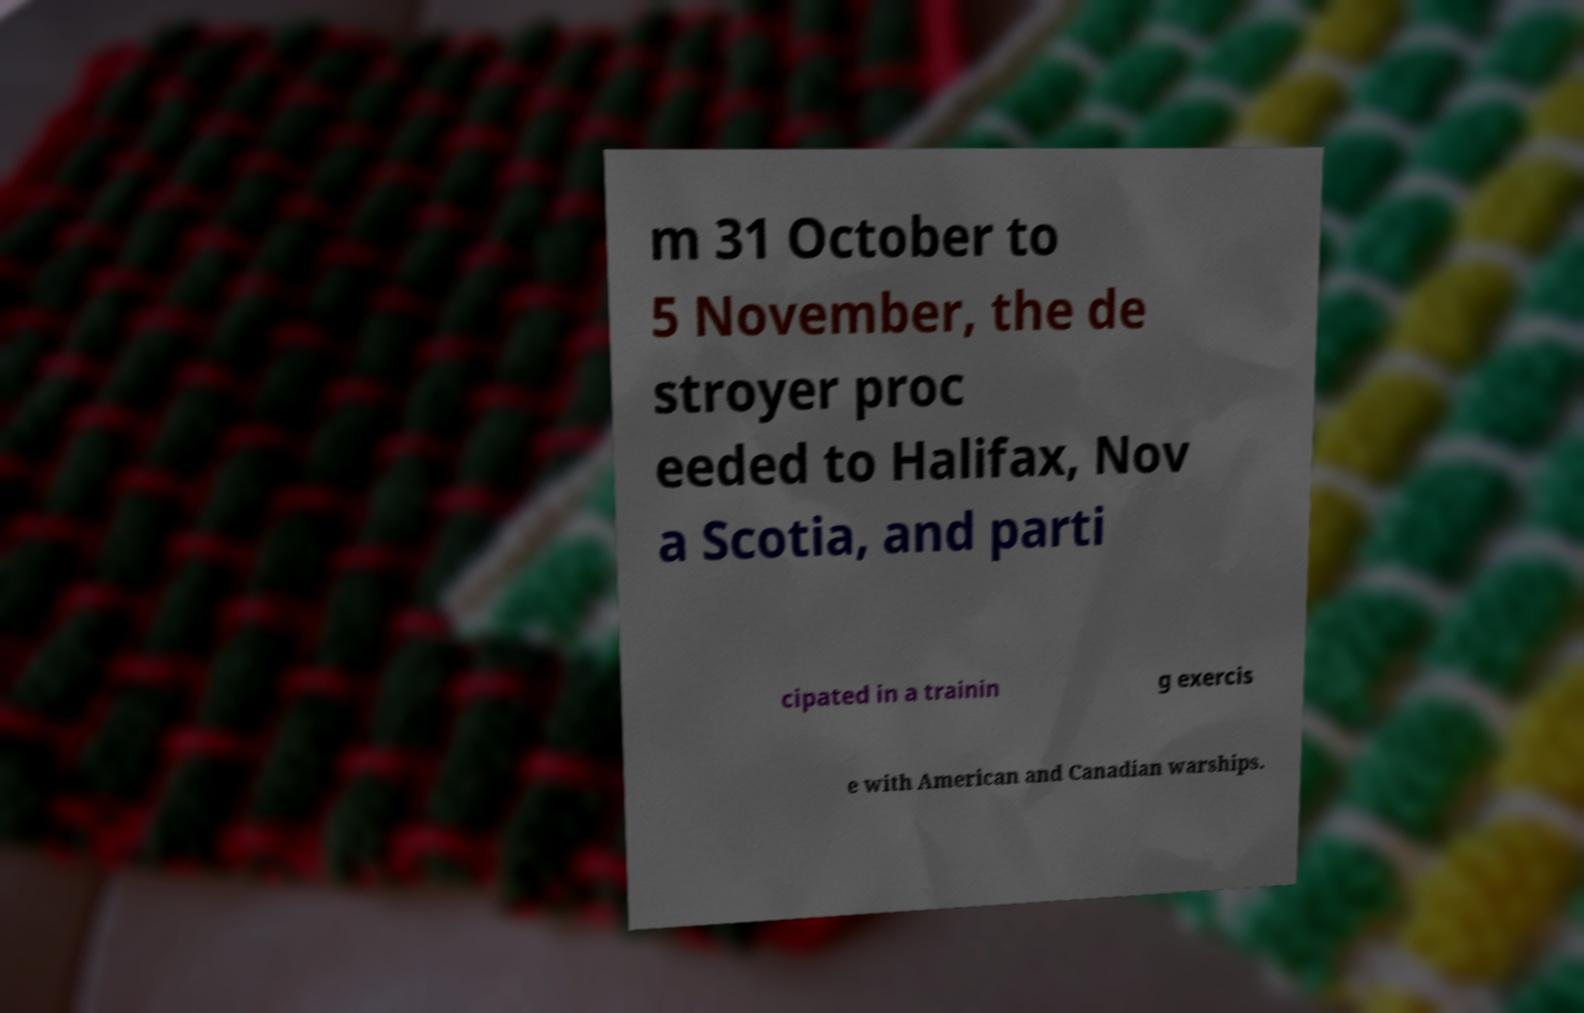For documentation purposes, I need the text within this image transcribed. Could you provide that? m 31 October to 5 November, the de stroyer proc eeded to Halifax, Nov a Scotia, and parti cipated in a trainin g exercis e with American and Canadian warships. 